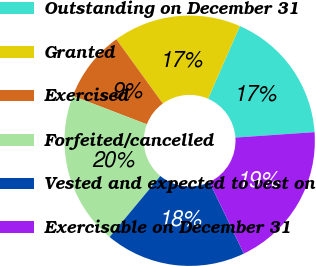Convert chart to OTSL. <chart><loc_0><loc_0><loc_500><loc_500><pie_chart><fcel>Outstanding on December 31<fcel>Granted<fcel>Exercised<fcel>Forfeited/cancelled<fcel>Vested and expected to vest on<fcel>Exercisable on December 31<nl><fcel>17.34%<fcel>16.53%<fcel>9.21%<fcel>19.79%<fcel>18.16%<fcel>18.97%<nl></chart> 